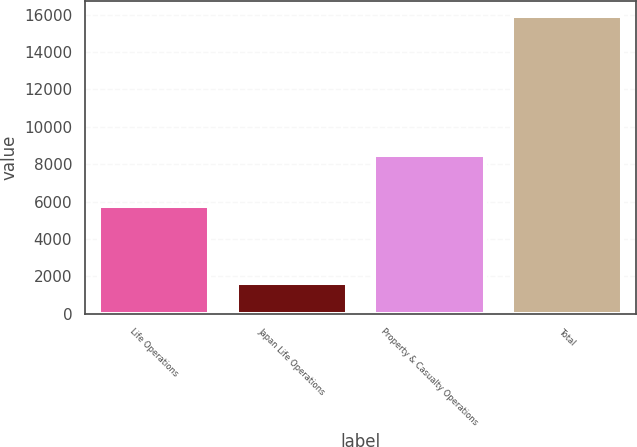<chart> <loc_0><loc_0><loc_500><loc_500><bar_chart><fcel>Life Operations<fcel>Japan Life Operations<fcel>Property & Casualty Operations<fcel>Total<nl><fcel>5786<fcel>1620<fcel>8509<fcel>15915<nl></chart> 